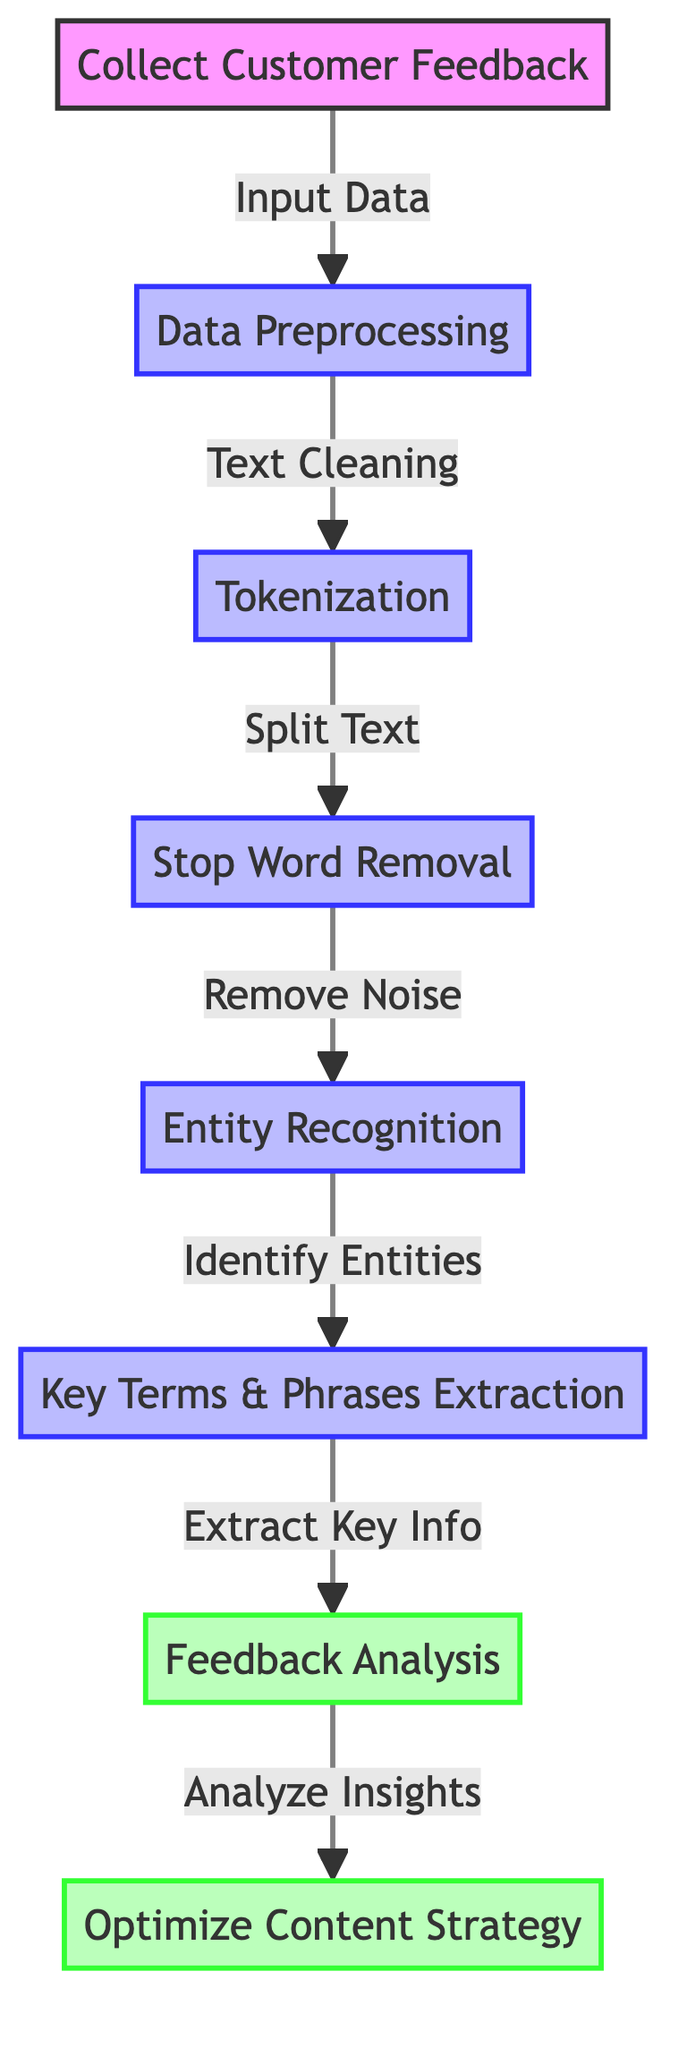What is the first step in the process? The diagram shows that "Collect Customer Feedback" is the initial step before any processing occurs, as indicated by the directed edge leading from it to the next node.
Answer: Collect Customer Feedback What type of operation is "Tokenization"? The diagram categorizes "Tokenization" as a process, as indicated by the applied class "processClass," differentiating it from other types of operations in the flow.
Answer: Process How many nodes are involved in the extraction of key information? By following the path from "Entity Recognition" to "Key Terms & Phrases Extraction," we see there are two nodes focused specifically on extracting relevant content.
Answer: Two What is the output of the "Feedback Analysis"? "Feedback Analysis" leads directly to "Optimize Content Strategy," indicating that the analysis serves as the basis for this strategic optimization step.
Answer: Optimize Content Strategy Which step involves cleaning the text? The diagram shows the "Data Preprocessing" node directly precedes "Tokenization," indicating that this preprocessing phase includes cleaning the data before further analysis.
Answer: Data Preprocessing What is removed during the "Stop Word Removal"? The directed edge indicates that "Stop Word Removal" is meant to eliminate noise, which refers to unnecessary words in the text data during the preprocessing phase.
Answer: Noise How does "Entity Recognition" relate to "Key Terms & Phrases Extraction"? The diagram indicates that "Entity Recognition" identifies relevant entities first, which feeds into the next step where those key terms and phrases are extracted, showing a direct dependency.
Answer: Identify Entities What flows into the "Optimization of Content Strategy"? The diagram shows that "Feedback Analysis" feeds into "Optimize Content Strategy", indicating that insights gained from analyzing feedback are essential for optimizing the content strategy.
Answer: Analyze Insights 